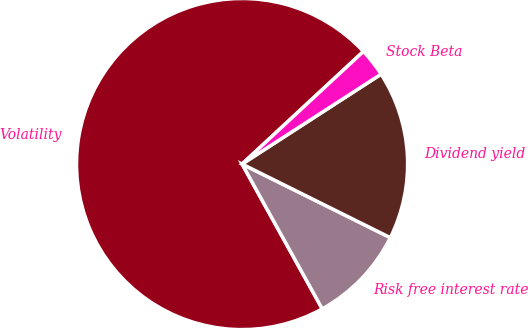Convert chart to OTSL. <chart><loc_0><loc_0><loc_500><loc_500><pie_chart><fcel>Volatility<fcel>Risk free interest rate<fcel>Dividend yield<fcel>Stock Beta<nl><fcel>71.15%<fcel>9.62%<fcel>16.47%<fcel>2.77%<nl></chart> 